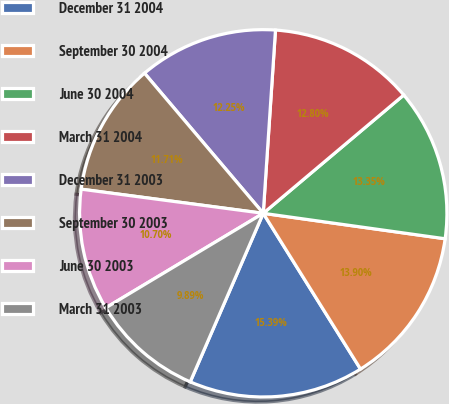<chart> <loc_0><loc_0><loc_500><loc_500><pie_chart><fcel>December 31 2004<fcel>September 30 2004<fcel>June 30 2004<fcel>March 31 2004<fcel>December 31 2003<fcel>September 30 2003<fcel>June 30 2003<fcel>March 31 2003<nl><fcel>15.39%<fcel>13.9%<fcel>13.35%<fcel>12.8%<fcel>12.25%<fcel>11.71%<fcel>10.7%<fcel>9.89%<nl></chart> 